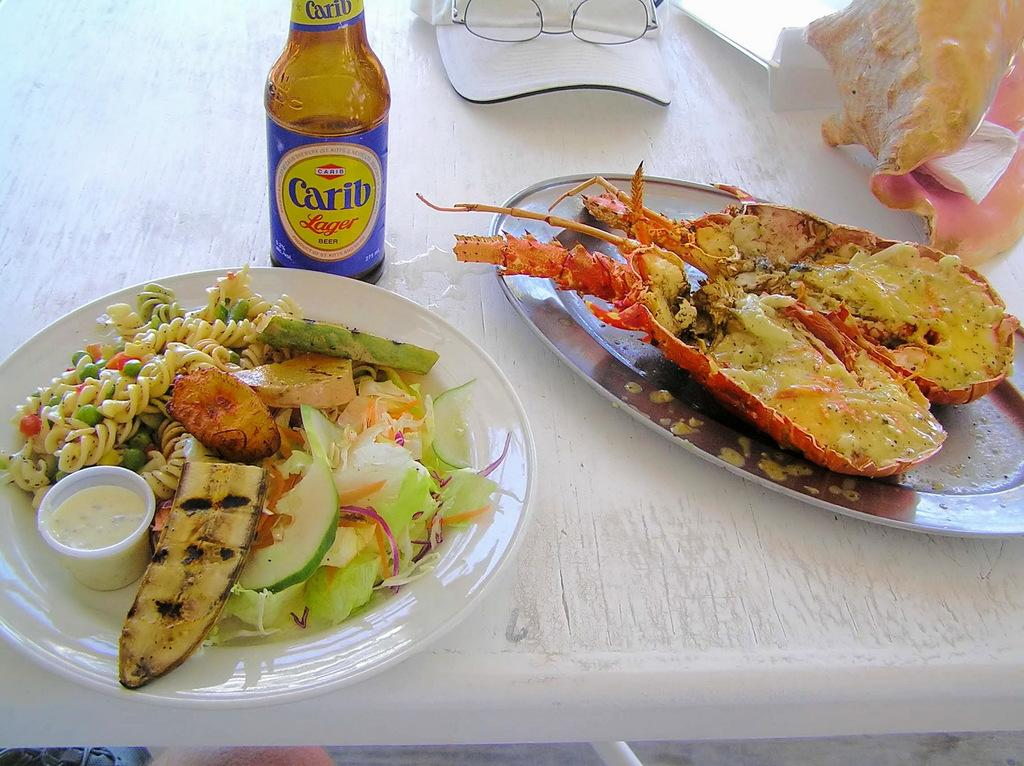What is on the plate that is visible in the image? There is a plate with food in the image. What else can be seen in the image besides the plate of food? There is a bottle and a cap visible in the image. What type of tableware is present on the table in the image? There are glasses on the table in the image. What news is being reported on the airplane in the image? There is no airplane present in the image, so no news can be reported from it. 